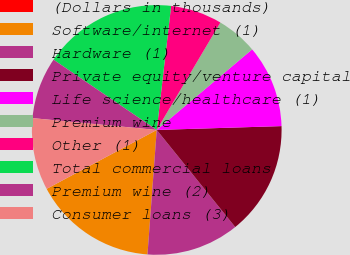<chart> <loc_0><loc_0><loc_500><loc_500><pie_chart><fcel>(Dollars in thousands)<fcel>Software/internet (1)<fcel>Hardware (1)<fcel>Private equity/venture capital<fcel>Life science/healthcare (1)<fcel>Premium wine<fcel>Other (1)<fcel>Total commercial loans<fcel>Premium wine (2)<fcel>Consumer loans (3)<nl><fcel>0.0%<fcel>16.0%<fcel>12.0%<fcel>14.67%<fcel>10.67%<fcel>5.33%<fcel>6.67%<fcel>17.33%<fcel>8.0%<fcel>9.33%<nl></chart> 